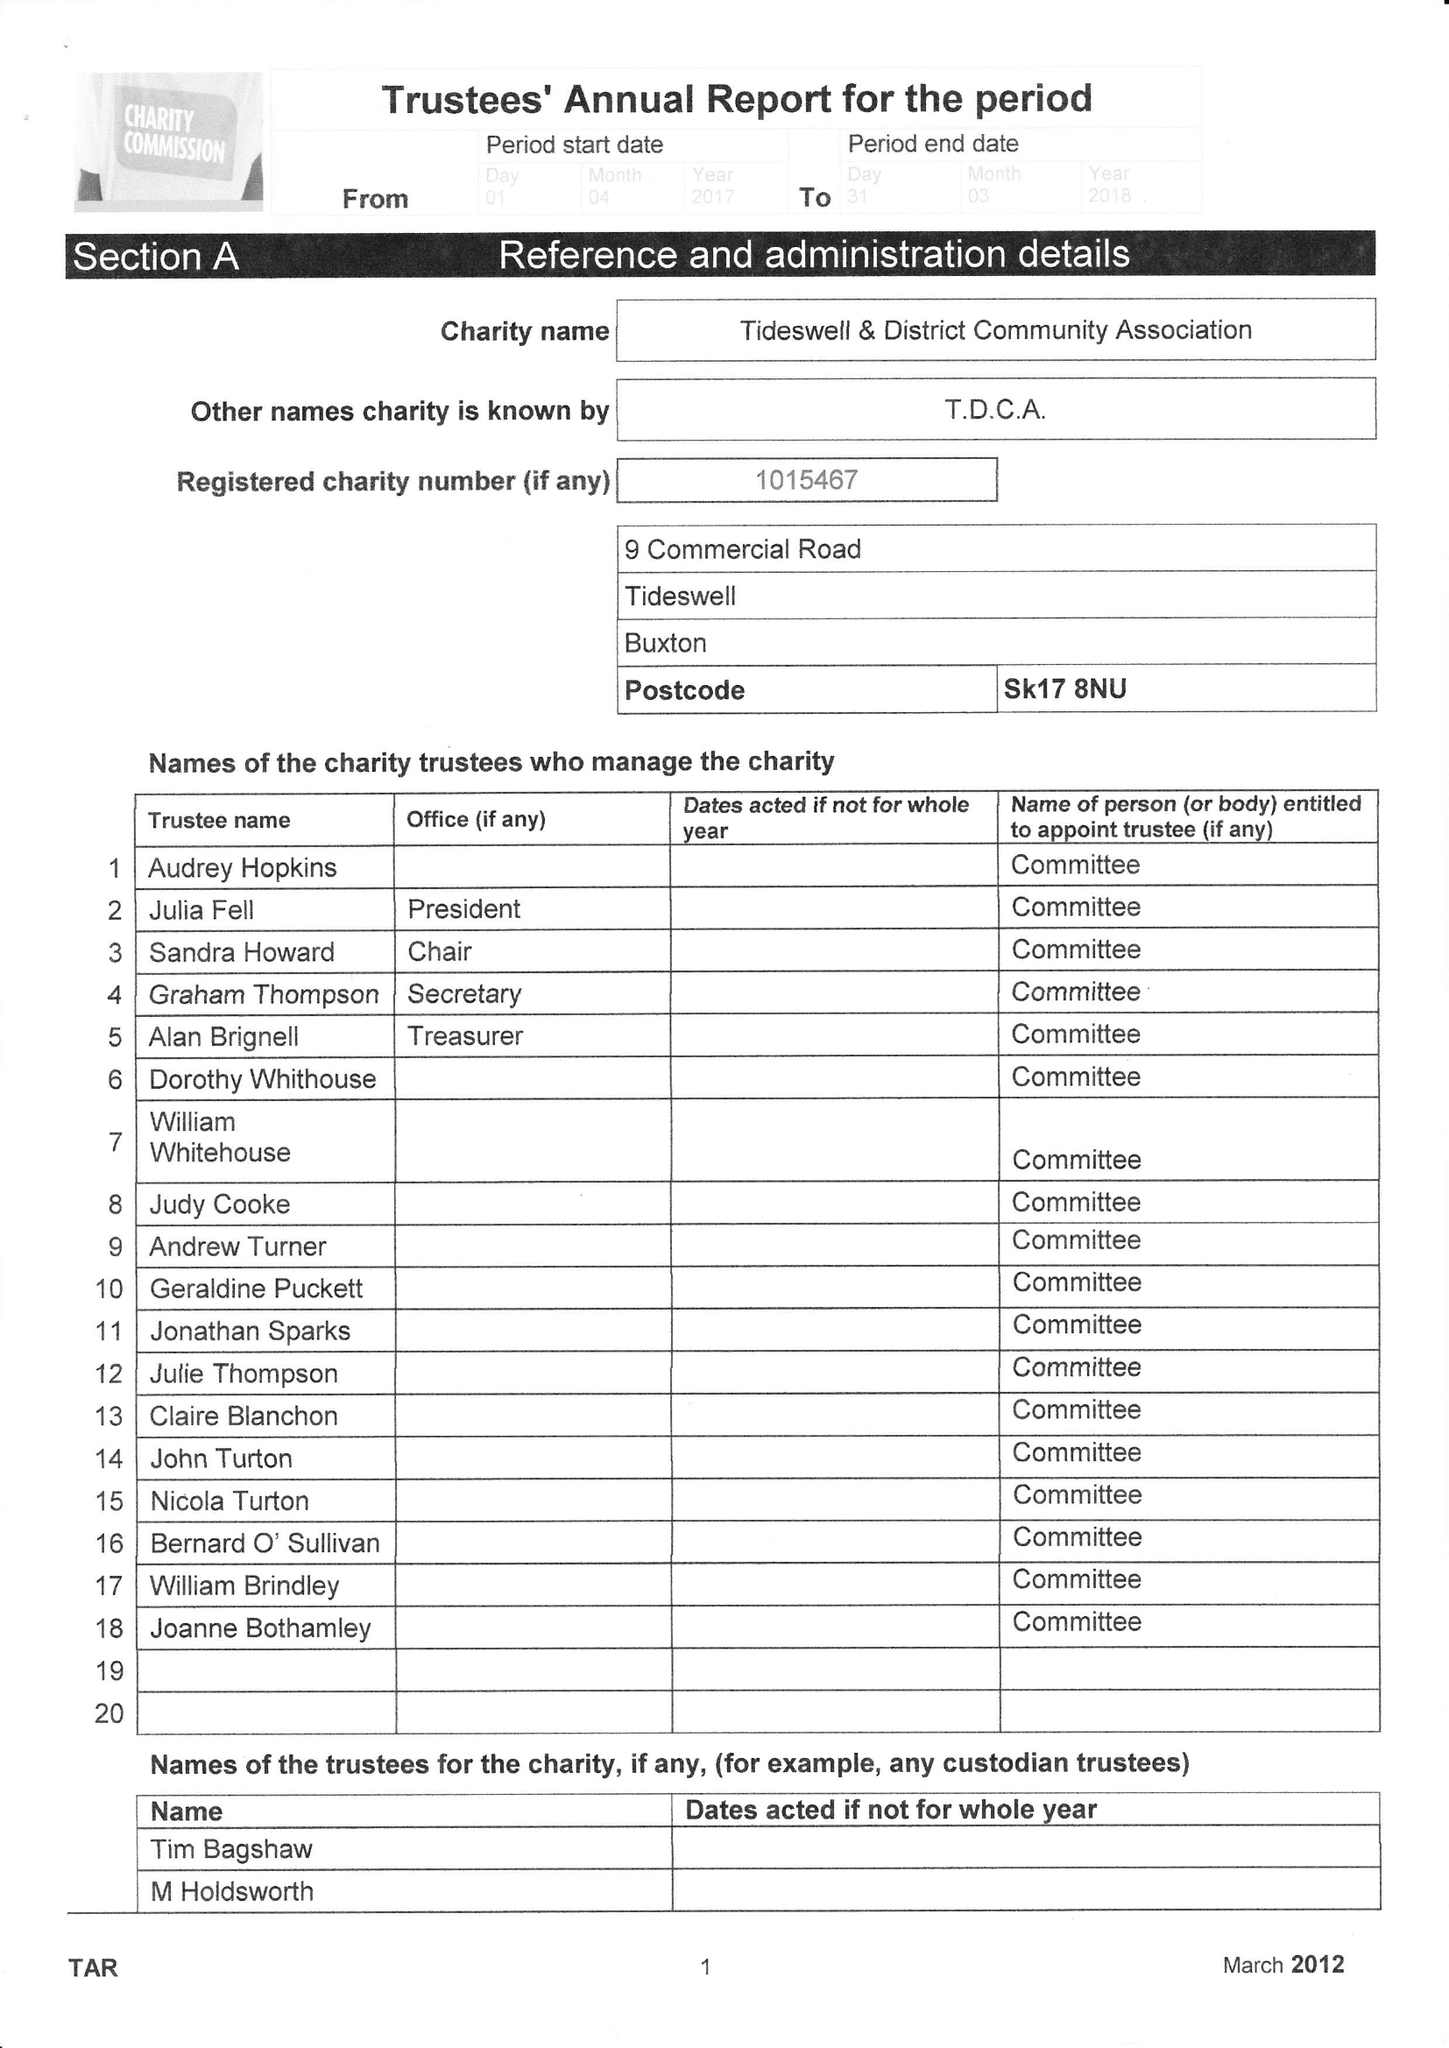What is the value for the report_date?
Answer the question using a single word or phrase. 2018-03-31 